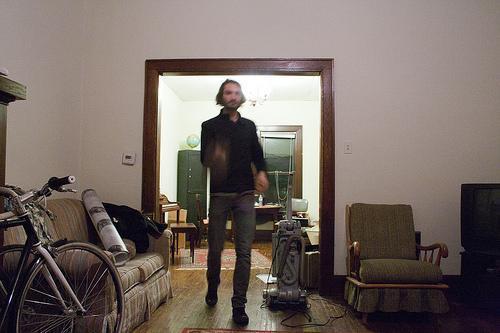How many people?
Give a very brief answer. 1. 